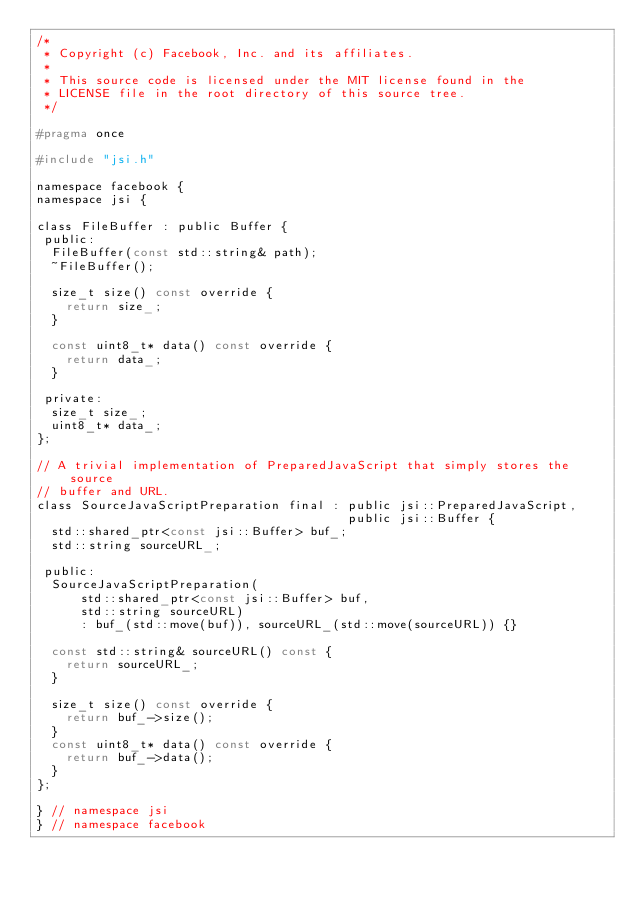<code> <loc_0><loc_0><loc_500><loc_500><_C_>/*
 * Copyright (c) Facebook, Inc. and its affiliates.
 *
 * This source code is licensed under the MIT license found in the
 * LICENSE file in the root directory of this source tree.
 */

#pragma once

#include "jsi.h"

namespace facebook {
namespace jsi {

class FileBuffer : public Buffer {
 public:
  FileBuffer(const std::string& path);
  ~FileBuffer();

  size_t size() const override {
    return size_;
  }

  const uint8_t* data() const override {
    return data_;
  }

 private:
  size_t size_;
  uint8_t* data_;
};

// A trivial implementation of PreparedJavaScript that simply stores the source
// buffer and URL.
class SourceJavaScriptPreparation final : public jsi::PreparedJavaScript,
                                          public jsi::Buffer {
  std::shared_ptr<const jsi::Buffer> buf_;
  std::string sourceURL_;

 public:
  SourceJavaScriptPreparation(
      std::shared_ptr<const jsi::Buffer> buf,
      std::string sourceURL)
      : buf_(std::move(buf)), sourceURL_(std::move(sourceURL)) {}

  const std::string& sourceURL() const {
    return sourceURL_;
  }

  size_t size() const override {
    return buf_->size();
  }
  const uint8_t* data() const override {
    return buf_->data();
  }
};

} // namespace jsi
} // namespace facebook
</code> 